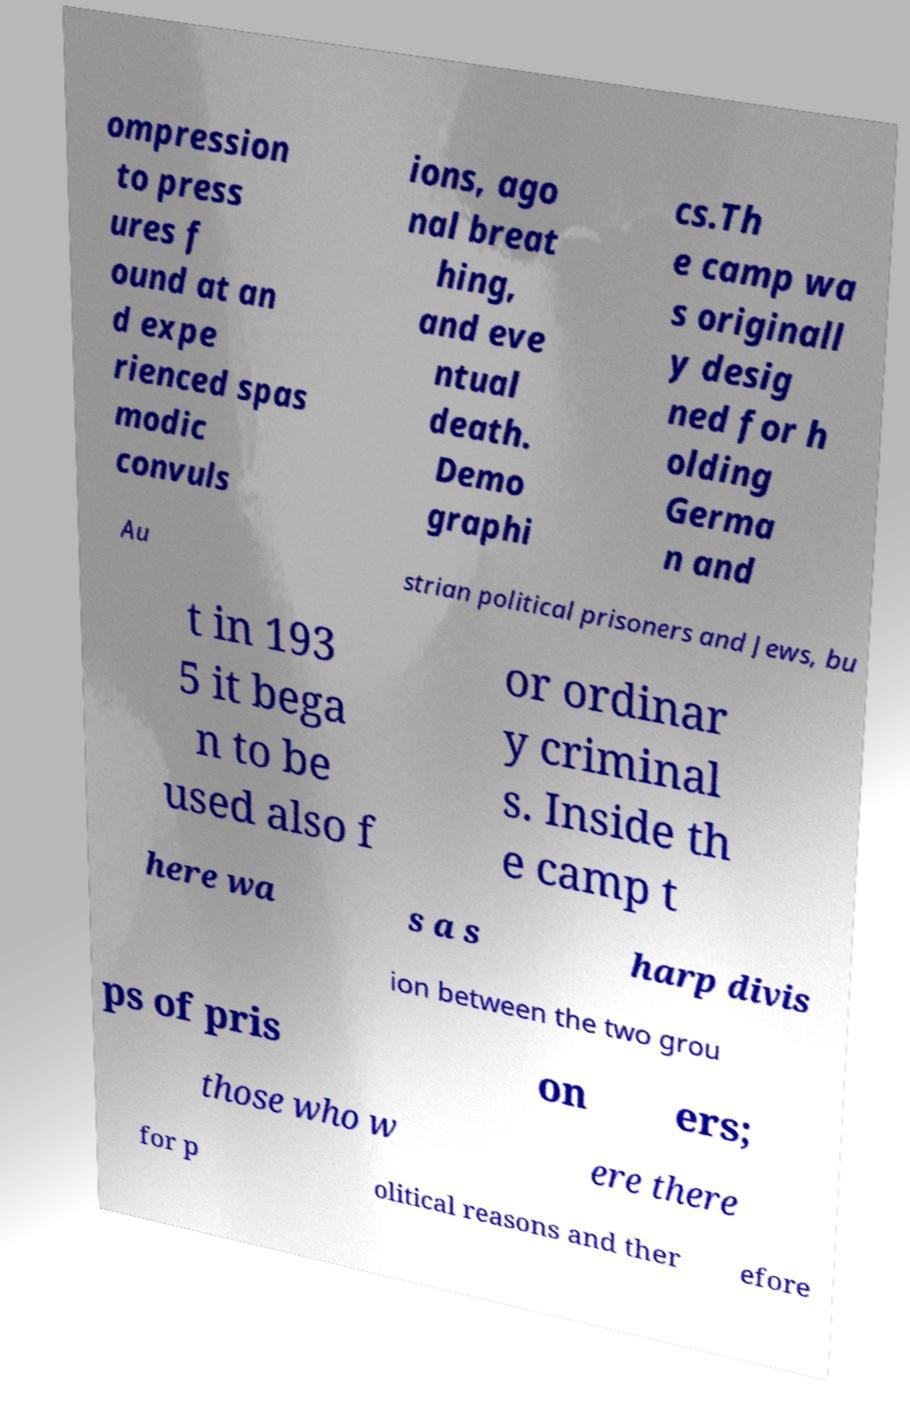There's text embedded in this image that I need extracted. Can you transcribe it verbatim? ompression to press ures f ound at an d expe rienced spas modic convuls ions, ago nal breat hing, and eve ntual death. Demo graphi cs.Th e camp wa s originall y desig ned for h olding Germa n and Au strian political prisoners and Jews, bu t in 193 5 it bega n to be used also f or ordinar y criminal s. Inside th e camp t here wa s a s harp divis ion between the two grou ps of pris on ers; those who w ere there for p olitical reasons and ther efore 